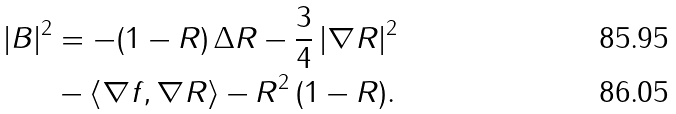<formula> <loc_0><loc_0><loc_500><loc_500>| B | ^ { 2 } & = - ( 1 - R ) \, \Delta R - \frac { 3 } { 4 } \, | \nabla R | ^ { 2 } \\ & - \langle \nabla f , \nabla R \rangle - R ^ { 2 } \, ( 1 - R ) .</formula> 